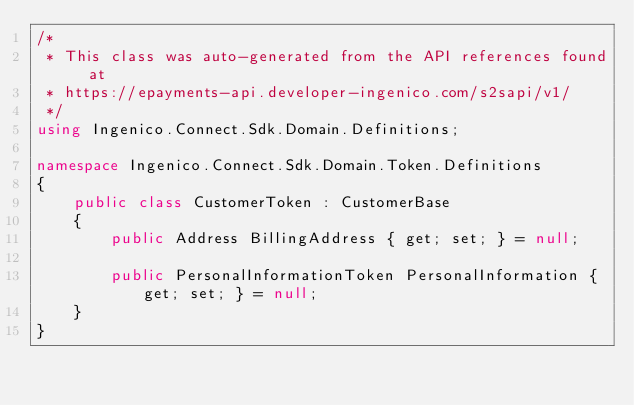Convert code to text. <code><loc_0><loc_0><loc_500><loc_500><_C#_>/*
 * This class was auto-generated from the API references found at
 * https://epayments-api.developer-ingenico.com/s2sapi/v1/
 */
using Ingenico.Connect.Sdk.Domain.Definitions;

namespace Ingenico.Connect.Sdk.Domain.Token.Definitions
{
    public class CustomerToken : CustomerBase
    {
        public Address BillingAddress { get; set; } = null;

        public PersonalInformationToken PersonalInformation { get; set; } = null;
    }
}
</code> 